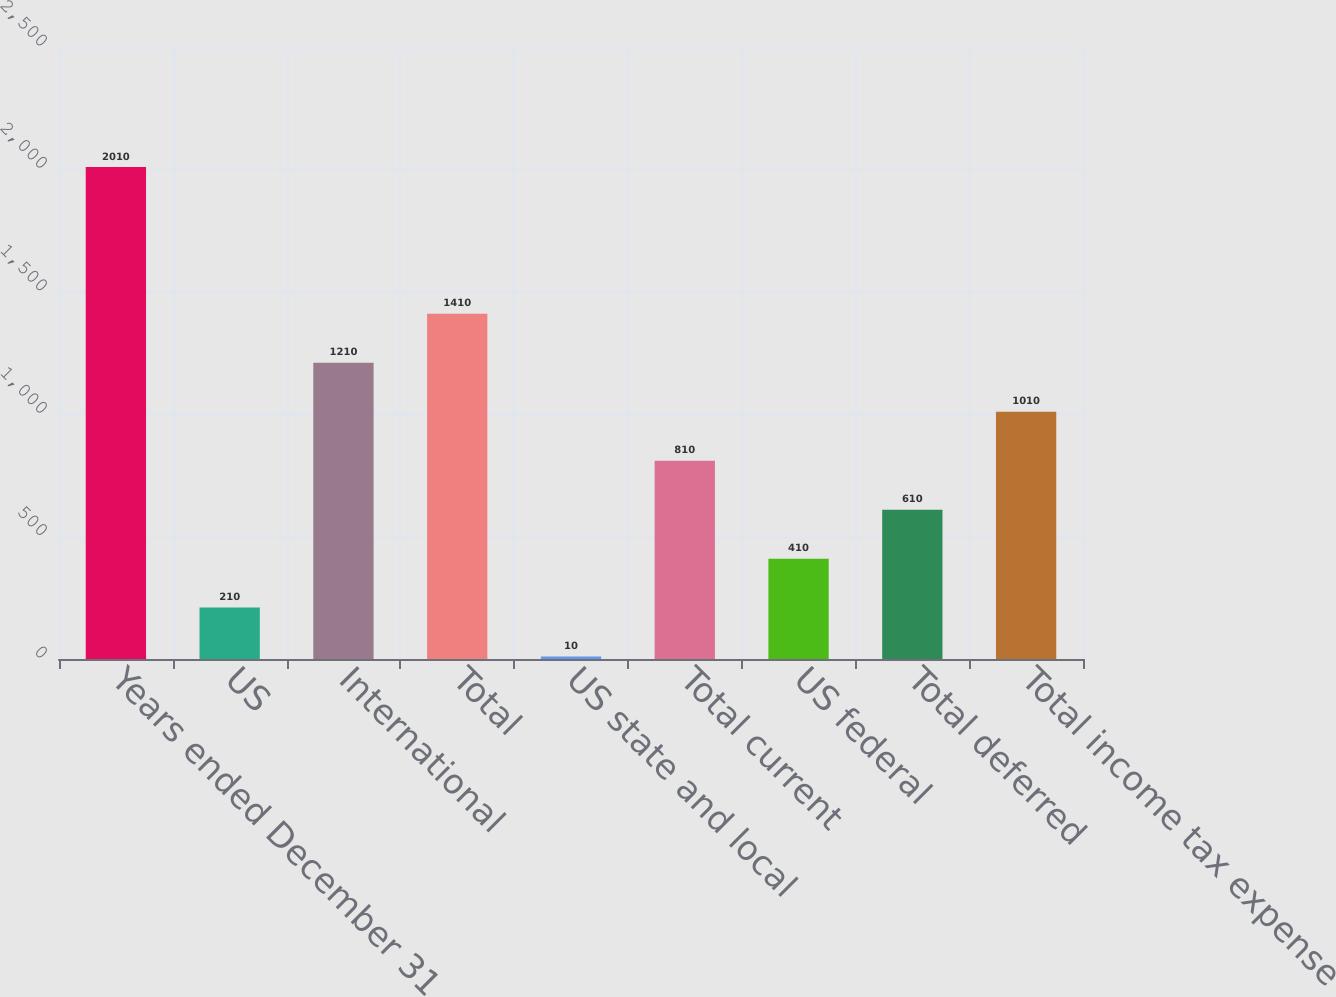<chart> <loc_0><loc_0><loc_500><loc_500><bar_chart><fcel>Years ended December 31<fcel>US<fcel>International<fcel>Total<fcel>US state and local<fcel>Total current<fcel>US federal<fcel>Total deferred<fcel>Total income tax expense<nl><fcel>2010<fcel>210<fcel>1210<fcel>1410<fcel>10<fcel>810<fcel>410<fcel>610<fcel>1010<nl></chart> 